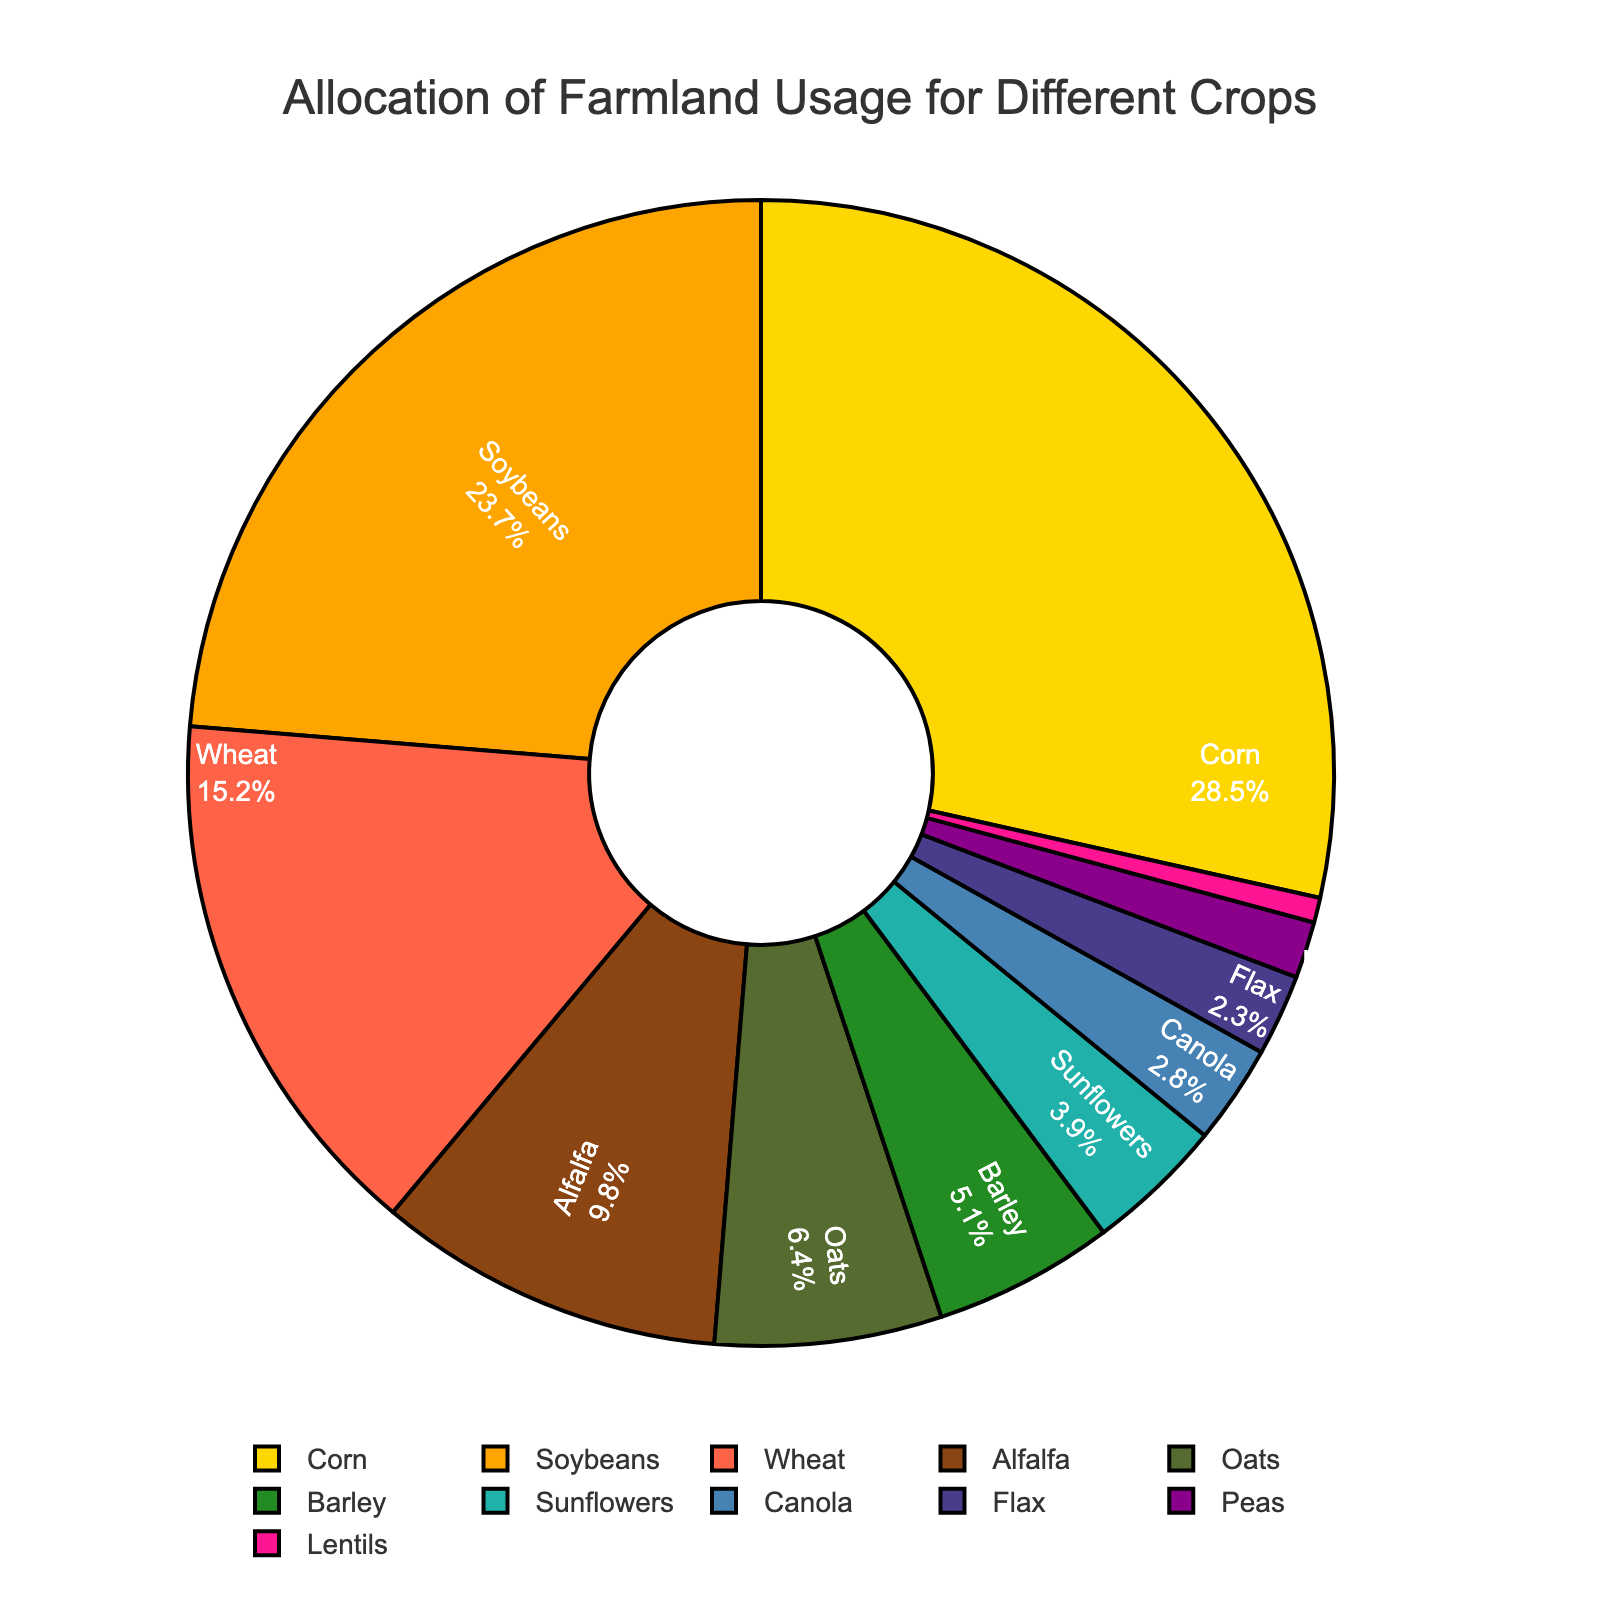What crop occupies the largest portion of farmland by percentage? By viewing the pie chart, identify the section with the largest area, which is labeled "Corn" with 28.5%.
Answer: Corn Which crop occupies less farmland: Barley or Flax? Look at the areas labeled "Barley" and "Flax"; "Barley" occupies 5.1% while "Flax" occupies 2.3%. Since 2.3% is less than 5.1%, Flax occupies less farmland than Barley.
Answer: Flax What is the combined percentage of farmland used for growing Soybeans and Alfalfa? Find the percentage occupied by "Soybeans" (23.7%) and "Alfalfa" (9.8%) and add them together: 23.7% + 9.8% = 33.5%.
Answer: 33.5% How many crops have an allocation greater than 10%? Inspect the pie chart for sections where the percentage is greater than 10%. These are Corn (28.5%), Soybeans (23.7%), and Wheat (15.2%).
Answer: 3 Which crop color-coded in green occupies the largest percentage of farmland? Identify sections in green shades and compare their percentages. "Soybeans" has a green color and the largest percentage among the green areas, 23.7%.
Answer: Soybeans Which is the smallest crop by farmland allocation, and what is its percentage? Find the smallest section, labeled "Lentils" with 0.7%.
Answer: Lentils, 0.7% Are the combined percentages of Oats and Barley greater or smaller than the percentage of Corn? Add the percentages of "Oats" (6.4%) and "Barley" (5.1%) and compare to "Corn" (28.5%). 6.4% + 5.1% = 11.5%, which is less than 28.5%.
Answer: Smaller What is the difference in farmland allocation between the crop with the highest percentage and the crop with the second highest percentage? "Corn" has the highest percentage (28.5%), and "Soybeans" have the second highest (23.7%). The difference is 28.5% - 23.7% = 4.8%.
Answer: 4.8% Compare the farmland percentages allocated to Sunflowers and Canola. Which one is higher? Find the percentages for "Sunflowers" (3.9%) and "Canola" (2.8%). Since 3.9% is greater than 2.8%, Sunflowers have a higher percentage.
Answer: Sunflowers What crops altogether occupy less than 5% of the farmland each? Identify sections labeled with percentages less than 5%. These include "Barley" (5.1%), "Sunflowers" (3.9%), "Canola" (2.8%), "Flax" (2.3%), "Peas" (1.6%), and "Lentils" (0.7%).
Answer: Sunflowers, Canola, Flax, Peas, Lentils 